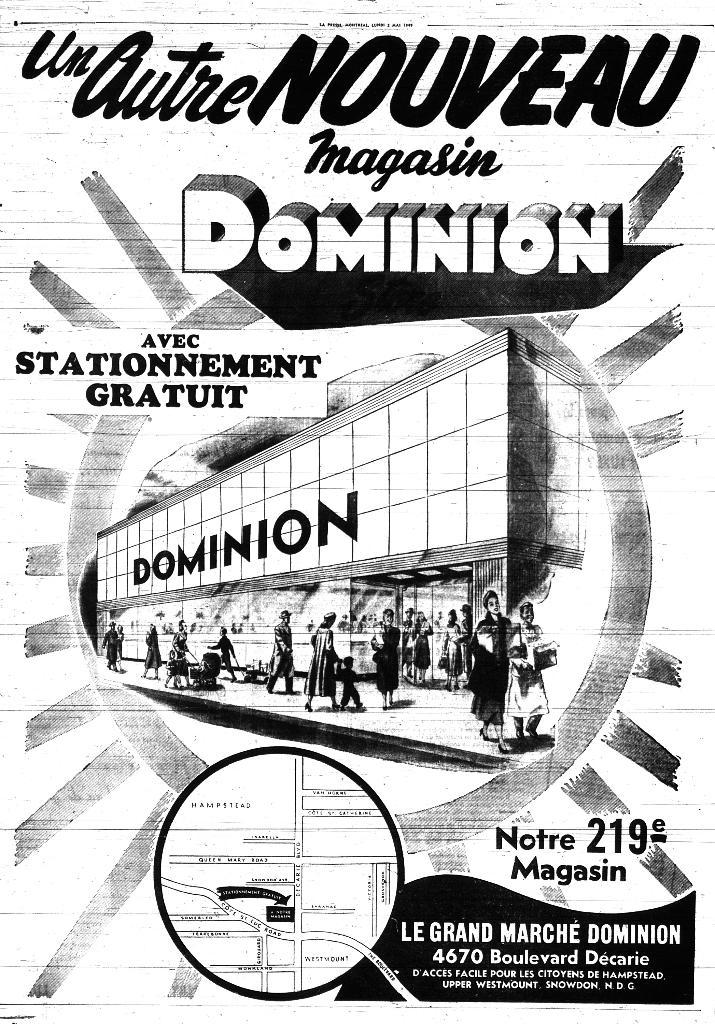Provide a one-sentence caption for the provided image. a poster advertising a department store called dominion. 